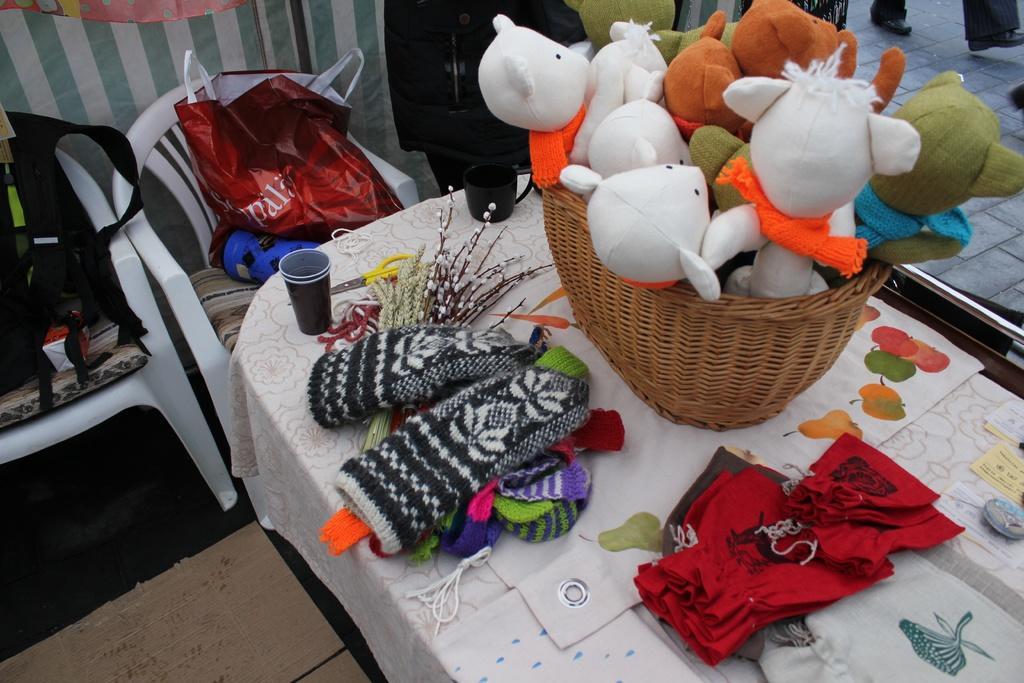Could you give a brief overview of what you see in this image? In this image we can see toys and some woolen clothes placed on the table. In the background we can see chairs, covers, curtain and window. 